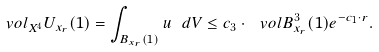<formula> <loc_0><loc_0><loc_500><loc_500>\ v o l _ { X ^ { 4 } } U _ { x _ { r } } ( 1 ) = \int _ { B _ { x _ { r } } ( 1 ) } u \ d V \leq c _ { 3 } \cdot \ v o l B _ { x _ { r } } ^ { 3 } ( 1 ) e ^ { - c _ { 1 } \cdot r } .</formula> 